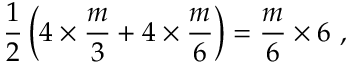Convert formula to latex. <formula><loc_0><loc_0><loc_500><loc_500>\frac { 1 } { 2 } \left ( 4 \times \frac { m } { 3 } + 4 \times \frac { m } { 6 } \right ) = \frac { m } { 6 } \times 6 ,</formula> 